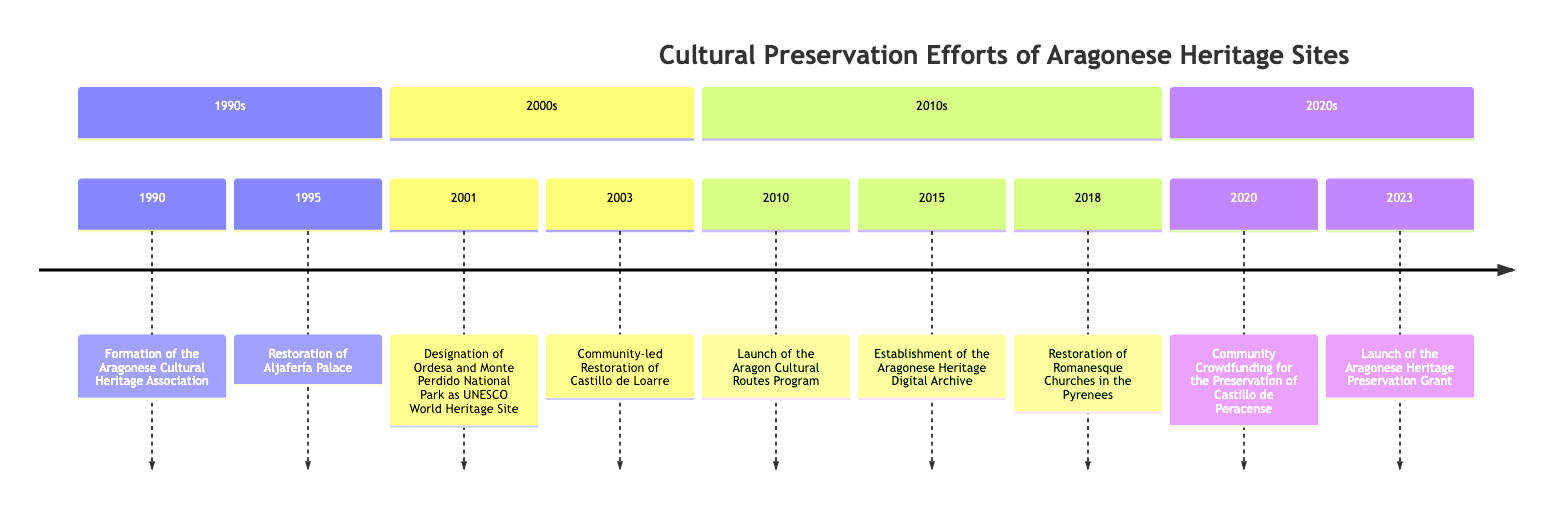What year was the Aragonese Cultural Heritage Association formed? The diagram indicates that the formation of the Aragonese Cultural Heritage Association occurred in the year 1990.
Answer: 1990 How many events are listed in the 2010s section? By counting the events listed in the 2010s section of the timeline, we find there are three events: Launch of the Aragon Cultural Routes Program (2010), Establishment of the Aragonese Heritage Digital Archive (2015), and Restoration of Romanesque Churches in the Pyrenees (2018).
Answer: 3 What event occurred immediately after the restoration of Aljafería Palace? In the timeline, the restoration of Aljafería Palace in 1995 is followed by the designation of Ordesa and Monte Perdido National Park as a UNESCO World Heritage Site in 2001, as there is no event listed for 1996-2000.
Answer: Designation of Ordesa and Monte Perdido National Park as UNESCO World Heritage Site Which community project took place in 2020? The timeline specifically notes the Community Crowdfunding for the Preservation of Castillo de Peracense event, which happened in the year 2020.
Answer: Community Crowdfunding for the Preservation of Castillo de Peracense What is the most recent event listed on the timeline? By examining the last entry in the timeline, the most recent event is the Launch of the Aragonese Heritage Preservation Grant, indicating that it occurred in the year 2023.
Answer: Launch of the Aragonese Heritage Preservation Grant How many years apart are the restoration efforts for Castillo de Loarre and Castillo de Peracense? The restoration efforts for Castillo de Loarre began in 2003, while the community crowdfunding for Castillo de Peracense took place in 2020. Therefore, the difference in years is 2020 - 2003 = 17 years.
Answer: 17 years 